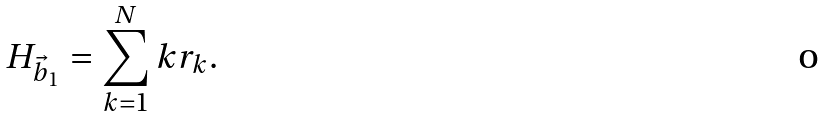<formula> <loc_0><loc_0><loc_500><loc_500>H _ { { \vec { b } } _ { 1 } } = \sum _ { k = 1 } ^ { N } k r _ { k } .</formula> 